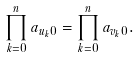Convert formula to latex. <formula><loc_0><loc_0><loc_500><loc_500>\prod _ { k = 0 } ^ { n } a _ { { u _ { k } } 0 } = \prod _ { k = 0 } ^ { n } a _ { { v _ { k } } 0 } .</formula> 